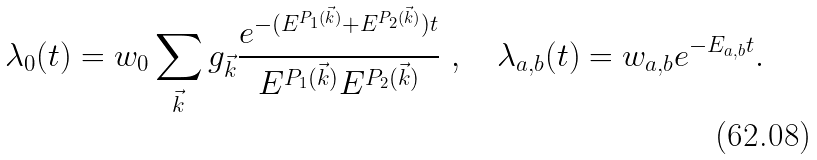Convert formula to latex. <formula><loc_0><loc_0><loc_500><loc_500>\lambda _ { 0 } ( t ) = w _ { 0 } \sum _ { \vec { k } } g _ { \vec { k } } \frac { e ^ { - ( E ^ { P _ { 1 } ( \vec { k } ) } + E ^ { P _ { 2 } ( \vec { k } ) } ) t } } { E ^ { P _ { 1 } ( \vec { k } ) } E ^ { P _ { 2 } ( \vec { k } ) } } \ , \quad \lambda _ { a , b } ( t ) = w _ { a , b } e ^ { - E _ { a , b } t } .</formula> 